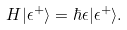Convert formula to latex. <formula><loc_0><loc_0><loc_500><loc_500>H | \epsilon ^ { + } \rangle = \hbar { \epsilon } | \epsilon ^ { + } \rangle .</formula> 